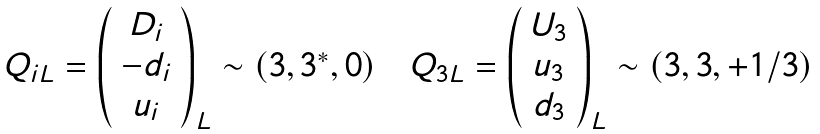Convert formula to latex. <formula><loc_0><loc_0><loc_500><loc_500>\begin{array} { c c c } Q _ { i L } = \left ( \begin{array} { c } D _ { i } \\ - d _ { i } \\ u _ { i } \end{array} \right ) _ { L } \sim ( 3 , 3 ^ { * } , 0 ) & & Q _ { 3 L } = \left ( \begin{array} { c } U _ { 3 } \\ u _ { 3 } \\ d _ { 3 } \end{array} \right ) _ { L } \sim ( 3 , 3 , + 1 / 3 ) \end{array}</formula> 